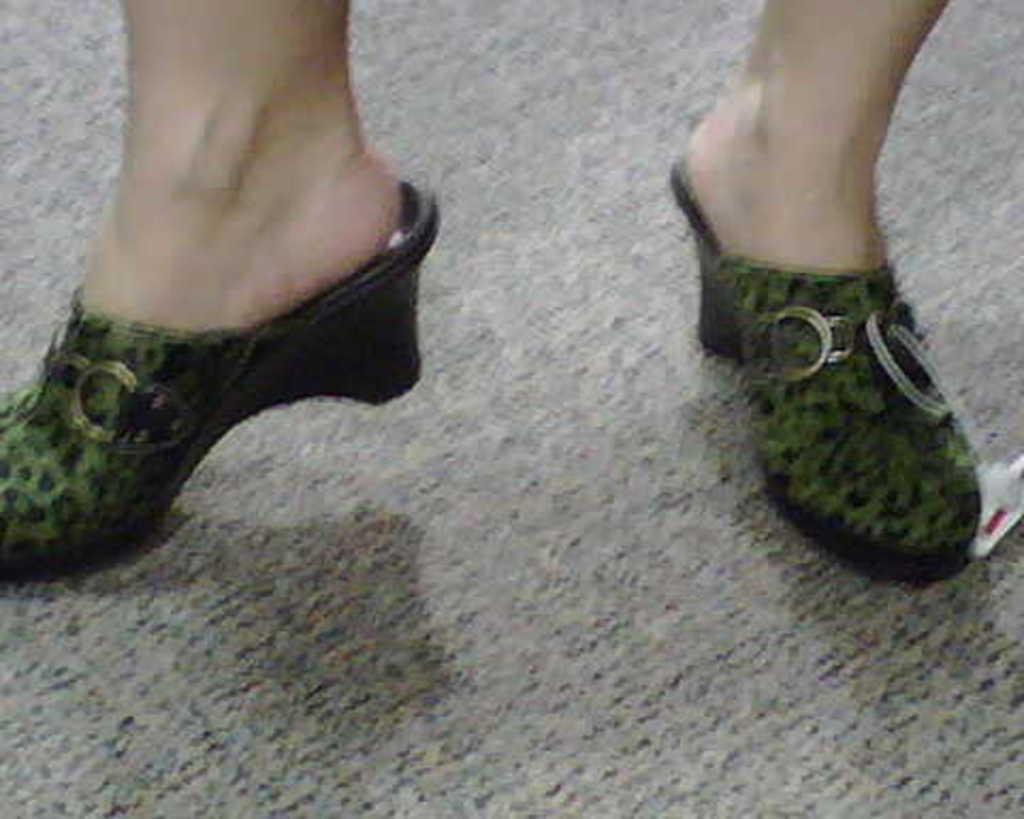What part of a person can be seen in the image? There are a person's legs visible in the image. What type of clothing is covering the person's feet in the image? Footwear is visible in the image. What type of fruit is hanging from the person's legs in the image? There is no fruit present in the image; it only shows a person's legs and footwear. 